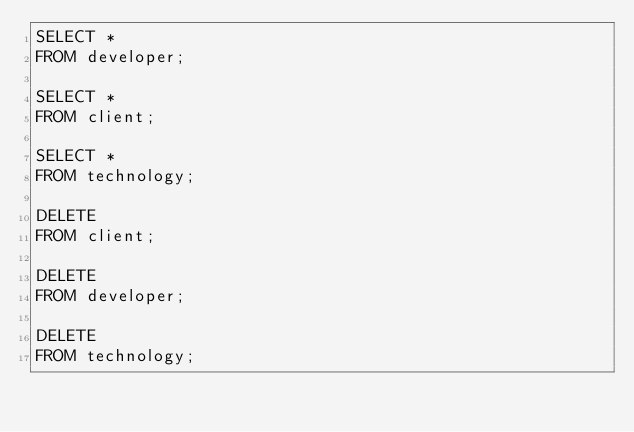<code> <loc_0><loc_0><loc_500><loc_500><_SQL_>SELECT *
FROM developer;

SELECT *
FROM client;

SELECT *
FROM technology;

DELETE
FROM client;

DELETE
FROM developer;

DELETE
FROM technology;
</code> 